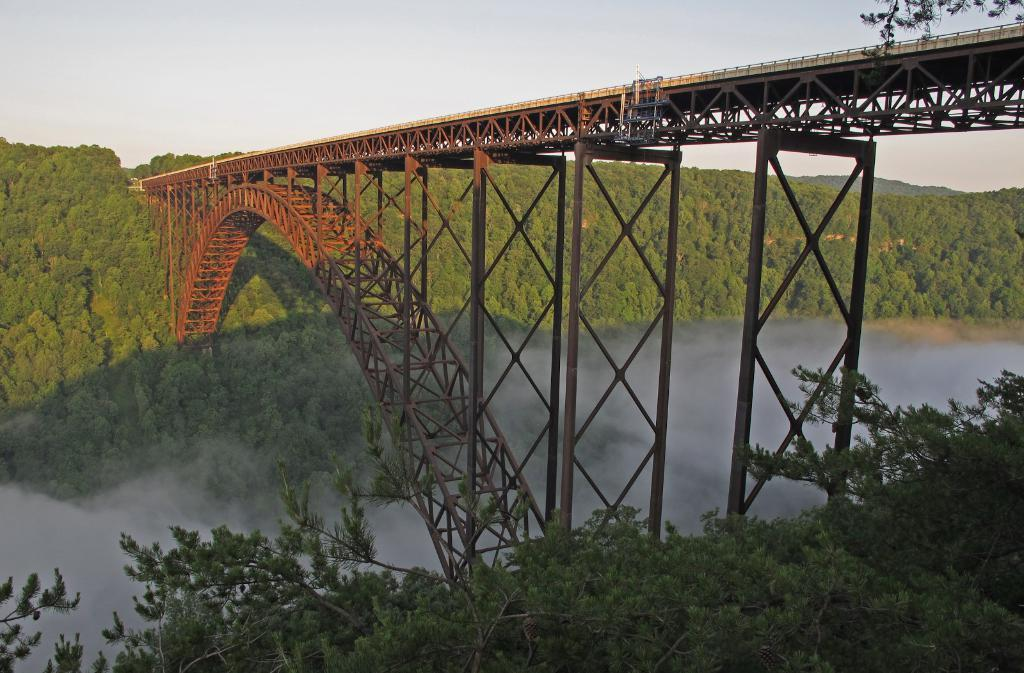What type of living organisms can be seen in the image? Plants can be seen in the image. How are the plants arranged in the image? The plants are arranged from left to right in the image. What can be seen in the background of the image? There is a bridge and trees in the background of the image. What verse is being recited by the plants in the image? There is no indication in the image that the plants are reciting a verse, as plants do not have the ability to speak or recite. 